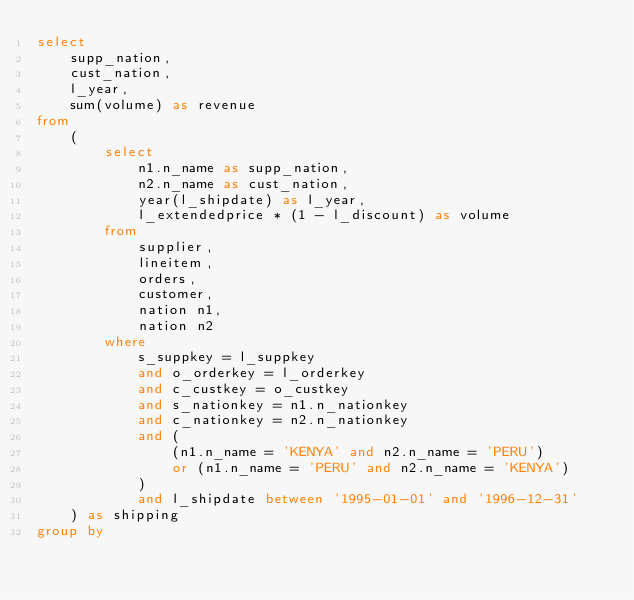Convert code to text. <code><loc_0><loc_0><loc_500><loc_500><_SQL_>select
	supp_nation,
	cust_nation,
	l_year,
	sum(volume) as revenue
from
	(
		select
			n1.n_name as supp_nation,
			n2.n_name as cust_nation,
			year(l_shipdate) as l_year,
			l_extendedprice * (1 - l_discount) as volume
		from
			supplier,
			lineitem,
			orders,
			customer,
			nation n1,
			nation n2
		where
			s_suppkey = l_suppkey
			and o_orderkey = l_orderkey
			and c_custkey = o_custkey
			and s_nationkey = n1.n_nationkey
			and c_nationkey = n2.n_nationkey
			and (
				(n1.n_name = 'KENYA' and n2.n_name = 'PERU')
				or (n1.n_name = 'PERU' and n2.n_name = 'KENYA')
			)
			and l_shipdate between '1995-01-01' and '1996-12-31'
	) as shipping
group by</code> 